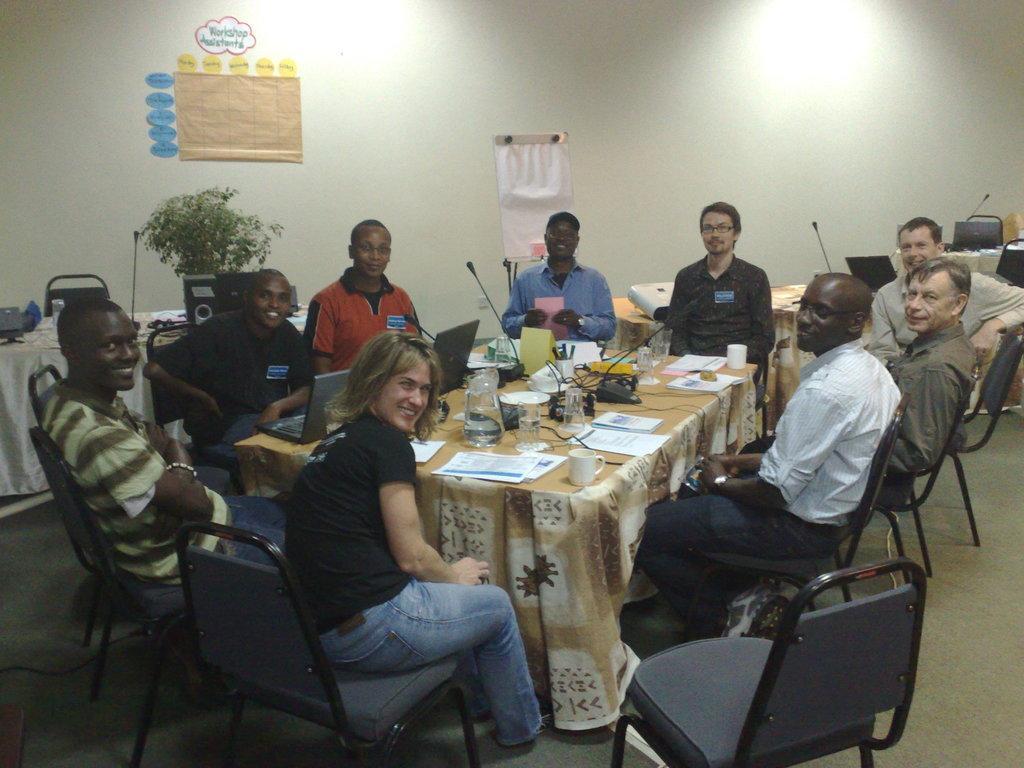Describe this image in one or two sentences. We can see a chart over a wall. this is a board. Here w can see all the persons sitting on chairs in front of a table and smiling and on the table we can see papers, mikes, water jar, water glasses. This is a floor. 